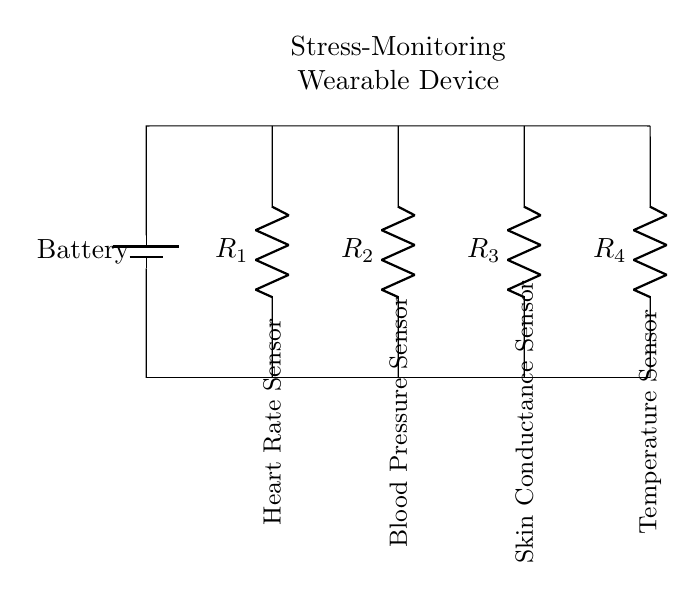What components are present in the circuit? The circuit diagram shows four resistors representing four different sensors connected in parallel. These are the heart rate sensor, blood pressure sensor, skin conductance sensor, and temperature sensor.
Answer: Four resistors (sensors) What type of circuit is this? This circuit is a parallel circuit because the components (sensors) are connected in such a way that they share the same voltage across them, while the total current is divided among them.
Answer: Parallel circuit What is the function of R1? R1 represents the heart rate sensor in this circuit, which monitors the user's heart rate as part of the stress monitoring.
Answer: Heart rate sensor How many sensors are integrated into the device? There are a total of four sensors integrated into the stress-monitoring device, as indicated by the four resistors in the circuit.
Answer: Four sensors What does the battery provide in this circuit? The battery in this circuit provides the necessary voltage for the sensors to operate, powering the wearable device.
Answer: Voltage 